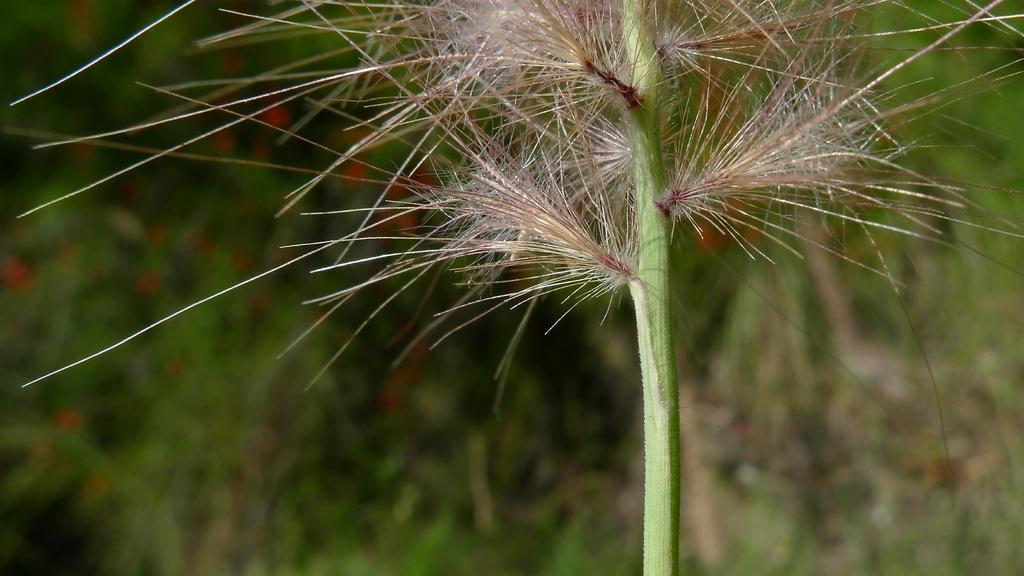What is present in the image? There is a plant in the image. Can you describe the background of the image? The background of the image is blurry. What finger is the plant using to read a book in the image? There is no finger or book present in the image; it only features a plant. What type of truck can be seen in the background of the image? There is no truck present in the image; the background is blurry. 